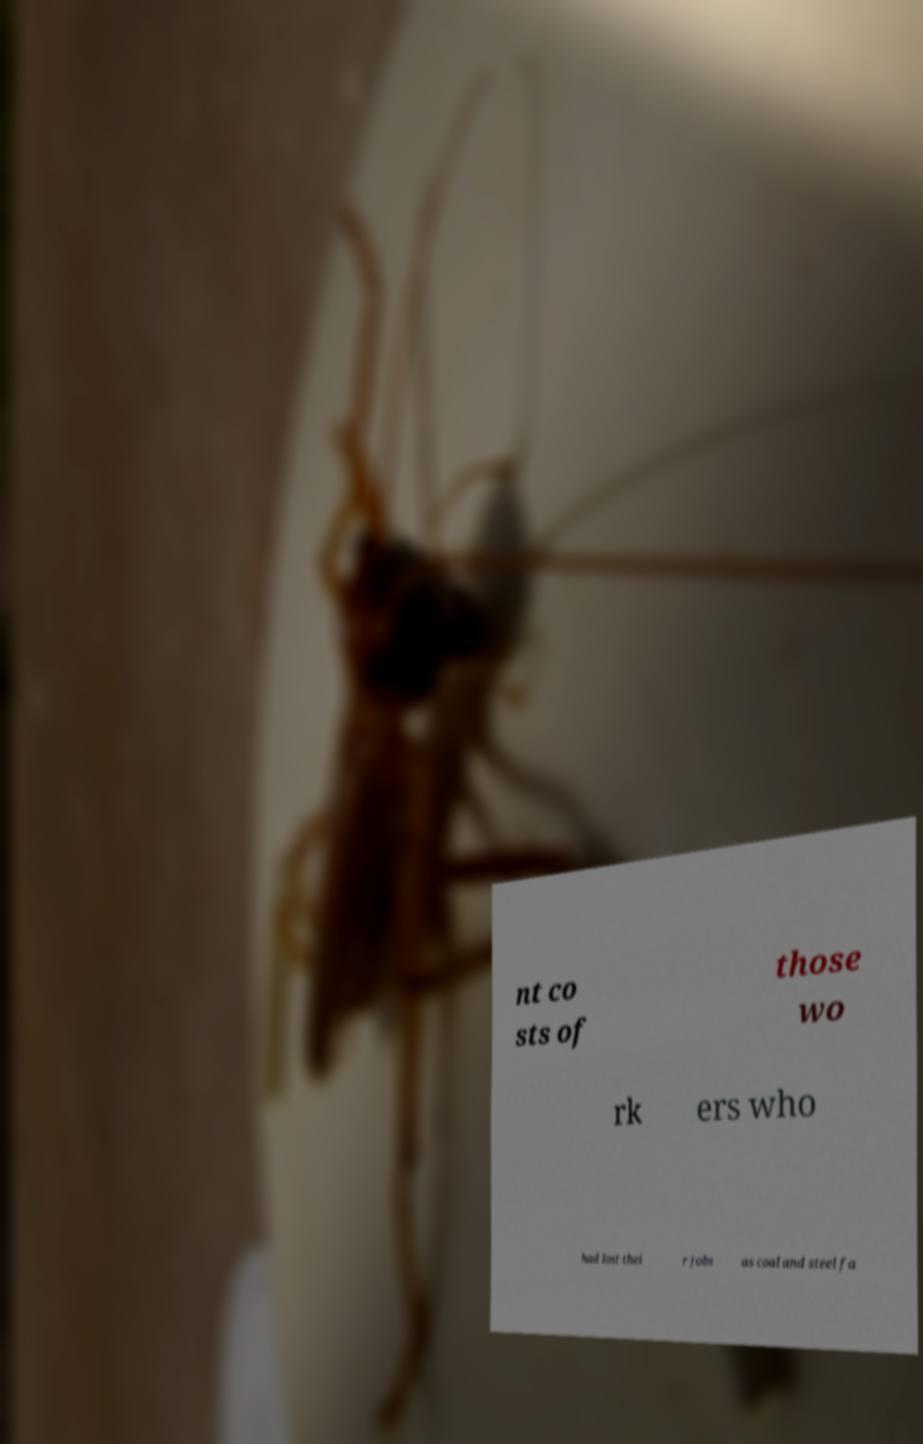Can you read and provide the text displayed in the image?This photo seems to have some interesting text. Can you extract and type it out for me? nt co sts of those wo rk ers who had lost thei r jobs as coal and steel fa 